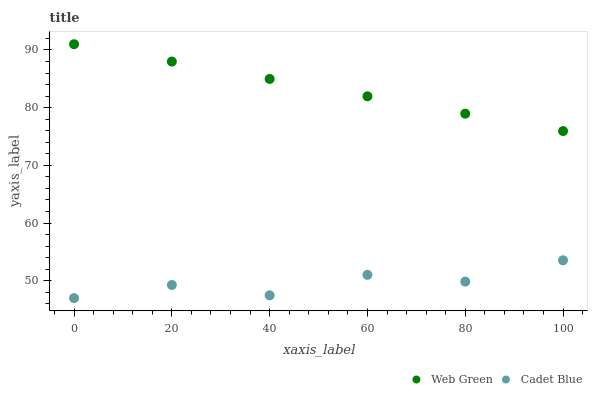Does Cadet Blue have the minimum area under the curve?
Answer yes or no. Yes. Does Web Green have the maximum area under the curve?
Answer yes or no. Yes. Does Web Green have the minimum area under the curve?
Answer yes or no. No. Is Web Green the smoothest?
Answer yes or no. Yes. Is Cadet Blue the roughest?
Answer yes or no. Yes. Is Web Green the roughest?
Answer yes or no. No. Does Cadet Blue have the lowest value?
Answer yes or no. Yes. Does Web Green have the lowest value?
Answer yes or no. No. Does Web Green have the highest value?
Answer yes or no. Yes. Is Cadet Blue less than Web Green?
Answer yes or no. Yes. Is Web Green greater than Cadet Blue?
Answer yes or no. Yes. Does Cadet Blue intersect Web Green?
Answer yes or no. No. 